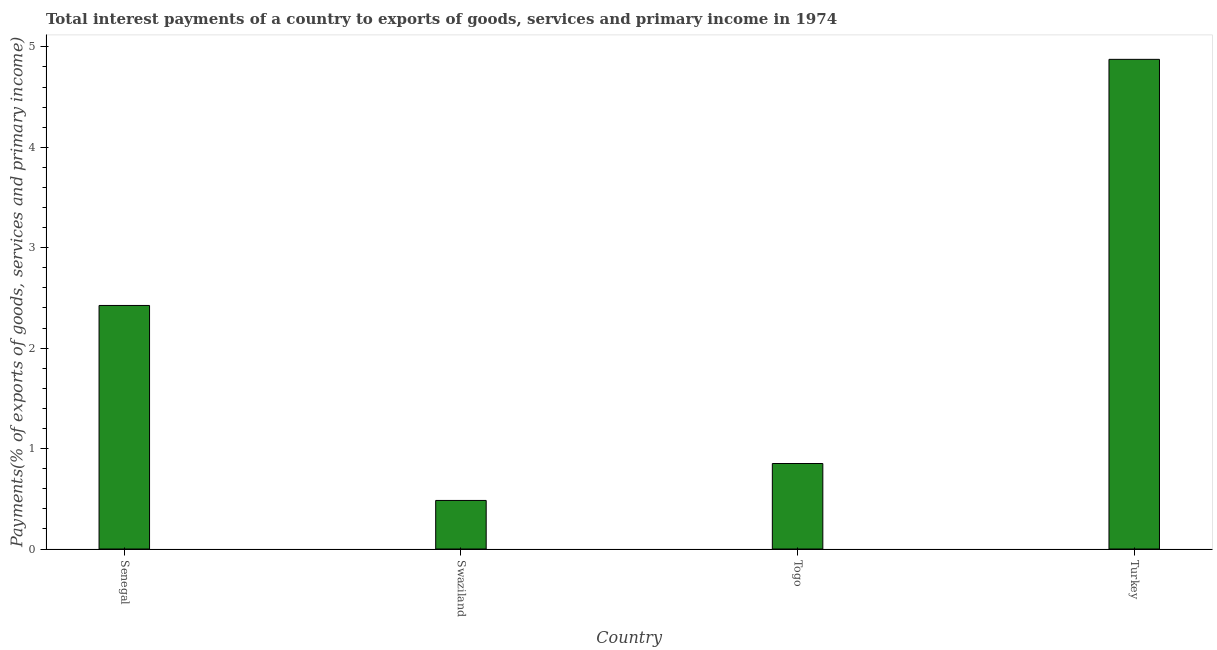Does the graph contain any zero values?
Give a very brief answer. No. Does the graph contain grids?
Provide a short and direct response. No. What is the title of the graph?
Make the answer very short. Total interest payments of a country to exports of goods, services and primary income in 1974. What is the label or title of the Y-axis?
Offer a very short reply. Payments(% of exports of goods, services and primary income). What is the total interest payments on external debt in Turkey?
Make the answer very short. 4.88. Across all countries, what is the maximum total interest payments on external debt?
Your answer should be compact. 4.88. Across all countries, what is the minimum total interest payments on external debt?
Keep it short and to the point. 0.48. In which country was the total interest payments on external debt maximum?
Give a very brief answer. Turkey. In which country was the total interest payments on external debt minimum?
Offer a very short reply. Swaziland. What is the sum of the total interest payments on external debt?
Keep it short and to the point. 8.63. What is the difference between the total interest payments on external debt in Swaziland and Togo?
Make the answer very short. -0.37. What is the average total interest payments on external debt per country?
Your answer should be very brief. 2.16. What is the median total interest payments on external debt?
Make the answer very short. 1.64. In how many countries, is the total interest payments on external debt greater than 1.2 %?
Ensure brevity in your answer.  2. What is the ratio of the total interest payments on external debt in Swaziland to that in Togo?
Provide a short and direct response. 0.57. Is the total interest payments on external debt in Senegal less than that in Togo?
Give a very brief answer. No. Is the difference between the total interest payments on external debt in Togo and Turkey greater than the difference between any two countries?
Provide a short and direct response. No. What is the difference between the highest and the second highest total interest payments on external debt?
Provide a succinct answer. 2.45. Is the sum of the total interest payments on external debt in Swaziland and Togo greater than the maximum total interest payments on external debt across all countries?
Make the answer very short. No. What is the difference between the highest and the lowest total interest payments on external debt?
Ensure brevity in your answer.  4.39. Are all the bars in the graph horizontal?
Provide a succinct answer. No. Are the values on the major ticks of Y-axis written in scientific E-notation?
Your answer should be very brief. No. What is the Payments(% of exports of goods, services and primary income) in Senegal?
Provide a short and direct response. 2.42. What is the Payments(% of exports of goods, services and primary income) in Swaziland?
Offer a terse response. 0.48. What is the Payments(% of exports of goods, services and primary income) in Togo?
Offer a very short reply. 0.85. What is the Payments(% of exports of goods, services and primary income) in Turkey?
Ensure brevity in your answer.  4.88. What is the difference between the Payments(% of exports of goods, services and primary income) in Senegal and Swaziland?
Keep it short and to the point. 1.94. What is the difference between the Payments(% of exports of goods, services and primary income) in Senegal and Togo?
Your answer should be very brief. 1.57. What is the difference between the Payments(% of exports of goods, services and primary income) in Senegal and Turkey?
Ensure brevity in your answer.  -2.45. What is the difference between the Payments(% of exports of goods, services and primary income) in Swaziland and Togo?
Make the answer very short. -0.37. What is the difference between the Payments(% of exports of goods, services and primary income) in Swaziland and Turkey?
Offer a very short reply. -4.39. What is the difference between the Payments(% of exports of goods, services and primary income) in Togo and Turkey?
Give a very brief answer. -4.02. What is the ratio of the Payments(% of exports of goods, services and primary income) in Senegal to that in Swaziland?
Offer a very short reply. 5.01. What is the ratio of the Payments(% of exports of goods, services and primary income) in Senegal to that in Togo?
Give a very brief answer. 2.85. What is the ratio of the Payments(% of exports of goods, services and primary income) in Senegal to that in Turkey?
Give a very brief answer. 0.5. What is the ratio of the Payments(% of exports of goods, services and primary income) in Swaziland to that in Togo?
Offer a terse response. 0.57. What is the ratio of the Payments(% of exports of goods, services and primary income) in Swaziland to that in Turkey?
Ensure brevity in your answer.  0.1. What is the ratio of the Payments(% of exports of goods, services and primary income) in Togo to that in Turkey?
Your answer should be very brief. 0.17. 